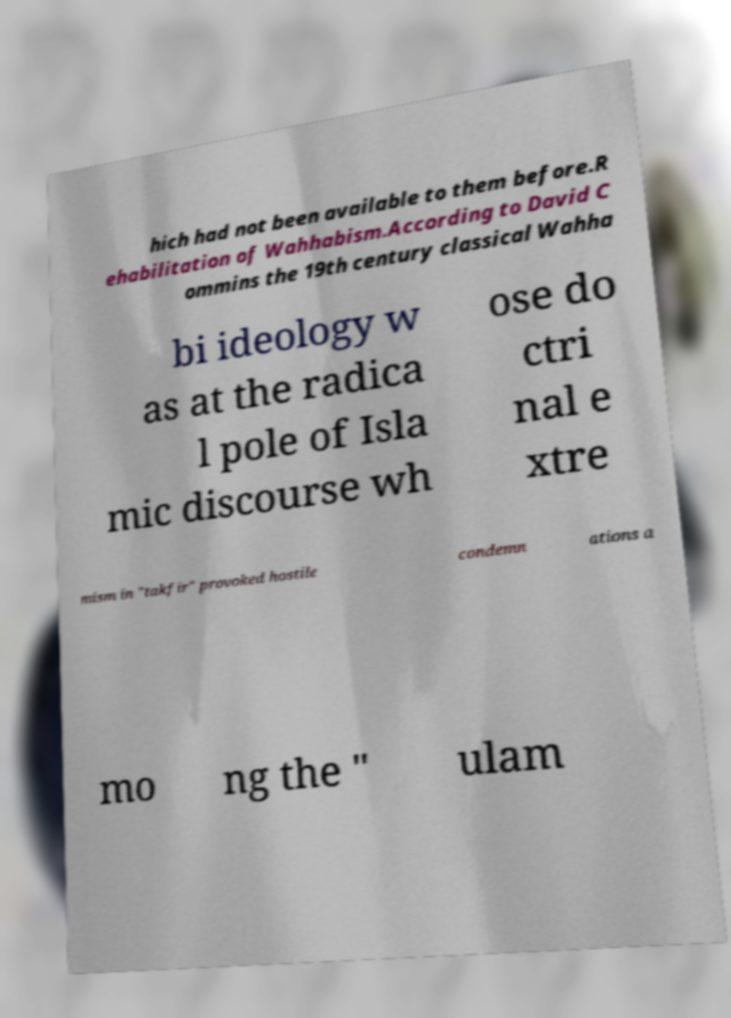Could you assist in decoding the text presented in this image and type it out clearly? hich had not been available to them before.R ehabilitation of Wahhabism.According to David C ommins the 19th century classical Wahha bi ideology w as at the radica l pole of Isla mic discourse wh ose do ctri nal e xtre mism in "takfir" provoked hostile condemn ations a mo ng the " ulam 